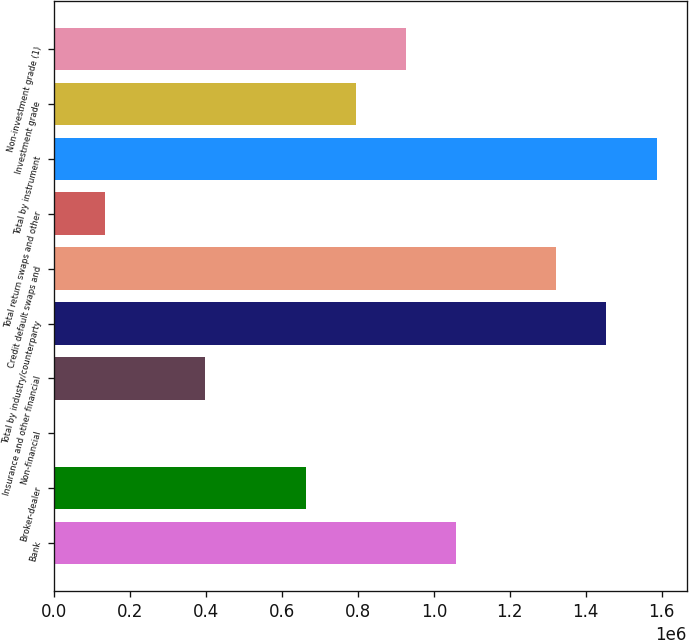<chart> <loc_0><loc_0><loc_500><loc_500><bar_chart><fcel>Bank<fcel>Broker-dealer<fcel>Non-financial<fcel>Insurance and other financial<fcel>Total by industry/counterparty<fcel>Credit default swaps and<fcel>Total return swaps and other<fcel>Total by instrument<fcel>Investment grade<fcel>Non-investment grade (1)<nl><fcel>1.05841e+06<fcel>661985<fcel>1277<fcel>397702<fcel>1.45483e+06<fcel>1.32269e+06<fcel>133419<fcel>1.58698e+06<fcel>794127<fcel>926268<nl></chart> 